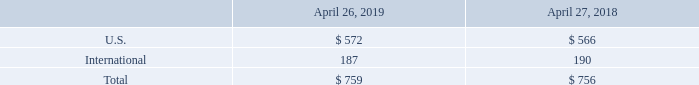16. Segment, Geographic, and Significant Customer Information
With the exception of property and equipment, we do not identify or allocate our long-lived assets by geographic area. The following table presents property and equipment information for geographic areas based on the physical location of the assets (in millions):
Which years does the table provide information for property and equipment information for geographic areas based on the physical location of the assets? 2019, 2018. What was the amount of property and equipment in U.S. in 2019?
Answer scale should be: million. 572. What was the total property and equipment in 2018?
Answer scale should be: million. 756. How many years did International property and equipment exceed $150 million? 2019##2018
Answer: 2. What was the change in U.S. property and equipment between 2018 and 2019?
Answer scale should be: million. 572-566
Answer: 6. What was the percentage change in the total amount of property and equipment between 2018 and 2019?
Answer scale should be: percent. (759-756)/756
Answer: 0.4. 